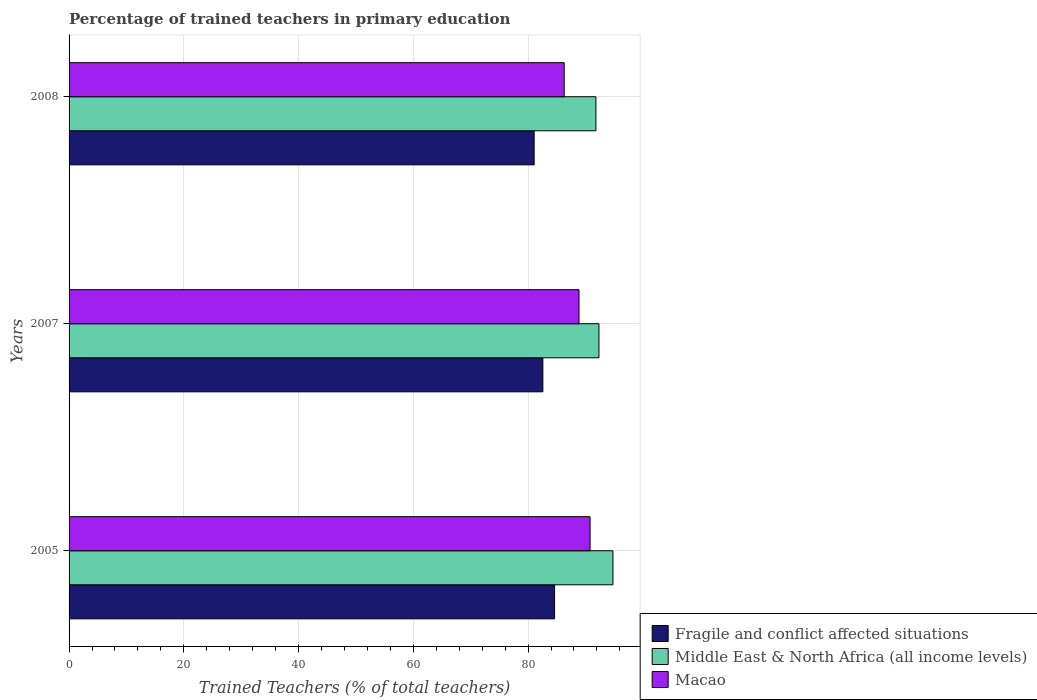How many groups of bars are there?
Your answer should be compact. 3. Are the number of bars on each tick of the Y-axis equal?
Ensure brevity in your answer.  Yes. What is the label of the 3rd group of bars from the top?
Provide a succinct answer. 2005. What is the percentage of trained teachers in Macao in 2008?
Provide a succinct answer. 86.3. Across all years, what is the maximum percentage of trained teachers in Middle East & North Africa (all income levels)?
Ensure brevity in your answer.  94.79. Across all years, what is the minimum percentage of trained teachers in Macao?
Provide a succinct answer. 86.3. In which year was the percentage of trained teachers in Middle East & North Africa (all income levels) minimum?
Keep it short and to the point. 2008. What is the total percentage of trained teachers in Macao in the graph?
Keep it short and to the point. 265.97. What is the difference between the percentage of trained teachers in Fragile and conflict affected situations in 2005 and that in 2008?
Your answer should be compact. 3.56. What is the difference between the percentage of trained teachers in Macao in 2005 and the percentage of trained teachers in Fragile and conflict affected situations in 2008?
Offer a terse response. 9.74. What is the average percentage of trained teachers in Middle East & North Africa (all income levels) per year?
Provide a succinct answer. 92.99. In the year 2005, what is the difference between the percentage of trained teachers in Middle East & North Africa (all income levels) and percentage of trained teachers in Macao?
Your answer should be compact. 3.99. What is the ratio of the percentage of trained teachers in Macao in 2005 to that in 2007?
Give a very brief answer. 1.02. Is the percentage of trained teachers in Macao in 2007 less than that in 2008?
Your answer should be very brief. No. Is the difference between the percentage of trained teachers in Middle East & North Africa (all income levels) in 2005 and 2008 greater than the difference between the percentage of trained teachers in Macao in 2005 and 2008?
Offer a terse response. No. What is the difference between the highest and the second highest percentage of trained teachers in Macao?
Your response must be concise. 1.93. What is the difference between the highest and the lowest percentage of trained teachers in Middle East & North Africa (all income levels)?
Offer a very short reply. 2.97. What does the 2nd bar from the top in 2005 represents?
Offer a terse response. Middle East & North Africa (all income levels). What does the 3rd bar from the bottom in 2005 represents?
Your answer should be compact. Macao. Is it the case that in every year, the sum of the percentage of trained teachers in Middle East & North Africa (all income levels) and percentage of trained teachers in Fragile and conflict affected situations is greater than the percentage of trained teachers in Macao?
Ensure brevity in your answer.  Yes. How many bars are there?
Offer a terse response. 9. Does the graph contain any zero values?
Your answer should be very brief. No. Does the graph contain grids?
Give a very brief answer. Yes. Where does the legend appear in the graph?
Ensure brevity in your answer.  Bottom right. How are the legend labels stacked?
Make the answer very short. Vertical. What is the title of the graph?
Offer a terse response. Percentage of trained teachers in primary education. Does "OECD members" appear as one of the legend labels in the graph?
Ensure brevity in your answer.  No. What is the label or title of the X-axis?
Your response must be concise. Trained Teachers (% of total teachers). What is the Trained Teachers (% of total teachers) in Fragile and conflict affected situations in 2005?
Give a very brief answer. 84.61. What is the Trained Teachers (% of total teachers) of Middle East & North Africa (all income levels) in 2005?
Offer a terse response. 94.79. What is the Trained Teachers (% of total teachers) of Macao in 2005?
Offer a terse response. 90.8. What is the Trained Teachers (% of total teachers) in Fragile and conflict affected situations in 2007?
Provide a short and direct response. 82.58. What is the Trained Teachers (% of total teachers) of Middle East & North Africa (all income levels) in 2007?
Offer a terse response. 92.35. What is the Trained Teachers (% of total teachers) in Macao in 2007?
Provide a succinct answer. 88.88. What is the Trained Teachers (% of total teachers) of Fragile and conflict affected situations in 2008?
Your response must be concise. 81.06. What is the Trained Teachers (% of total teachers) in Middle East & North Africa (all income levels) in 2008?
Make the answer very short. 91.82. What is the Trained Teachers (% of total teachers) of Macao in 2008?
Ensure brevity in your answer.  86.3. Across all years, what is the maximum Trained Teachers (% of total teachers) of Fragile and conflict affected situations?
Your response must be concise. 84.61. Across all years, what is the maximum Trained Teachers (% of total teachers) in Middle East & North Africa (all income levels)?
Make the answer very short. 94.79. Across all years, what is the maximum Trained Teachers (% of total teachers) in Macao?
Offer a terse response. 90.8. Across all years, what is the minimum Trained Teachers (% of total teachers) in Fragile and conflict affected situations?
Give a very brief answer. 81.06. Across all years, what is the minimum Trained Teachers (% of total teachers) of Middle East & North Africa (all income levels)?
Make the answer very short. 91.82. Across all years, what is the minimum Trained Teachers (% of total teachers) of Macao?
Ensure brevity in your answer.  86.3. What is the total Trained Teachers (% of total teachers) of Fragile and conflict affected situations in the graph?
Your answer should be compact. 248.25. What is the total Trained Teachers (% of total teachers) of Middle East & North Africa (all income levels) in the graph?
Provide a short and direct response. 278.97. What is the total Trained Teachers (% of total teachers) in Macao in the graph?
Make the answer very short. 265.97. What is the difference between the Trained Teachers (% of total teachers) in Fragile and conflict affected situations in 2005 and that in 2007?
Your answer should be compact. 2.04. What is the difference between the Trained Teachers (% of total teachers) of Middle East & North Africa (all income levels) in 2005 and that in 2007?
Ensure brevity in your answer.  2.44. What is the difference between the Trained Teachers (% of total teachers) in Macao in 2005 and that in 2007?
Offer a very short reply. 1.93. What is the difference between the Trained Teachers (% of total teachers) in Fragile and conflict affected situations in 2005 and that in 2008?
Offer a very short reply. 3.56. What is the difference between the Trained Teachers (% of total teachers) in Middle East & North Africa (all income levels) in 2005 and that in 2008?
Offer a very short reply. 2.97. What is the difference between the Trained Teachers (% of total teachers) in Macao in 2005 and that in 2008?
Your response must be concise. 4.51. What is the difference between the Trained Teachers (% of total teachers) in Fragile and conflict affected situations in 2007 and that in 2008?
Offer a terse response. 1.52. What is the difference between the Trained Teachers (% of total teachers) in Middle East & North Africa (all income levels) in 2007 and that in 2008?
Your response must be concise. 0.53. What is the difference between the Trained Teachers (% of total teachers) of Macao in 2007 and that in 2008?
Give a very brief answer. 2.58. What is the difference between the Trained Teachers (% of total teachers) in Fragile and conflict affected situations in 2005 and the Trained Teachers (% of total teachers) in Middle East & North Africa (all income levels) in 2007?
Offer a very short reply. -7.74. What is the difference between the Trained Teachers (% of total teachers) of Fragile and conflict affected situations in 2005 and the Trained Teachers (% of total teachers) of Macao in 2007?
Your answer should be compact. -4.26. What is the difference between the Trained Teachers (% of total teachers) of Middle East & North Africa (all income levels) in 2005 and the Trained Teachers (% of total teachers) of Macao in 2007?
Your answer should be very brief. 5.92. What is the difference between the Trained Teachers (% of total teachers) in Fragile and conflict affected situations in 2005 and the Trained Teachers (% of total teachers) in Middle East & North Africa (all income levels) in 2008?
Offer a very short reply. -7.21. What is the difference between the Trained Teachers (% of total teachers) in Fragile and conflict affected situations in 2005 and the Trained Teachers (% of total teachers) in Macao in 2008?
Offer a very short reply. -1.68. What is the difference between the Trained Teachers (% of total teachers) of Middle East & North Africa (all income levels) in 2005 and the Trained Teachers (% of total teachers) of Macao in 2008?
Provide a succinct answer. 8.5. What is the difference between the Trained Teachers (% of total teachers) in Fragile and conflict affected situations in 2007 and the Trained Teachers (% of total teachers) in Middle East & North Africa (all income levels) in 2008?
Offer a terse response. -9.25. What is the difference between the Trained Teachers (% of total teachers) in Fragile and conflict affected situations in 2007 and the Trained Teachers (% of total teachers) in Macao in 2008?
Make the answer very short. -3.72. What is the difference between the Trained Teachers (% of total teachers) of Middle East & North Africa (all income levels) in 2007 and the Trained Teachers (% of total teachers) of Macao in 2008?
Keep it short and to the point. 6.06. What is the average Trained Teachers (% of total teachers) in Fragile and conflict affected situations per year?
Provide a succinct answer. 82.75. What is the average Trained Teachers (% of total teachers) in Middle East & North Africa (all income levels) per year?
Offer a terse response. 92.99. What is the average Trained Teachers (% of total teachers) of Macao per year?
Your answer should be very brief. 88.66. In the year 2005, what is the difference between the Trained Teachers (% of total teachers) in Fragile and conflict affected situations and Trained Teachers (% of total teachers) in Middle East & North Africa (all income levels)?
Give a very brief answer. -10.18. In the year 2005, what is the difference between the Trained Teachers (% of total teachers) in Fragile and conflict affected situations and Trained Teachers (% of total teachers) in Macao?
Provide a short and direct response. -6.19. In the year 2005, what is the difference between the Trained Teachers (% of total teachers) in Middle East & North Africa (all income levels) and Trained Teachers (% of total teachers) in Macao?
Provide a short and direct response. 3.99. In the year 2007, what is the difference between the Trained Teachers (% of total teachers) in Fragile and conflict affected situations and Trained Teachers (% of total teachers) in Middle East & North Africa (all income levels)?
Offer a terse response. -9.78. In the year 2007, what is the difference between the Trained Teachers (% of total teachers) of Fragile and conflict affected situations and Trained Teachers (% of total teachers) of Macao?
Offer a terse response. -6.3. In the year 2007, what is the difference between the Trained Teachers (% of total teachers) of Middle East & North Africa (all income levels) and Trained Teachers (% of total teachers) of Macao?
Your answer should be very brief. 3.48. In the year 2008, what is the difference between the Trained Teachers (% of total teachers) in Fragile and conflict affected situations and Trained Teachers (% of total teachers) in Middle East & North Africa (all income levels)?
Your response must be concise. -10.77. In the year 2008, what is the difference between the Trained Teachers (% of total teachers) of Fragile and conflict affected situations and Trained Teachers (% of total teachers) of Macao?
Offer a very short reply. -5.24. In the year 2008, what is the difference between the Trained Teachers (% of total teachers) of Middle East & North Africa (all income levels) and Trained Teachers (% of total teachers) of Macao?
Your response must be concise. 5.53. What is the ratio of the Trained Teachers (% of total teachers) of Fragile and conflict affected situations in 2005 to that in 2007?
Make the answer very short. 1.02. What is the ratio of the Trained Teachers (% of total teachers) in Middle East & North Africa (all income levels) in 2005 to that in 2007?
Offer a very short reply. 1.03. What is the ratio of the Trained Teachers (% of total teachers) of Macao in 2005 to that in 2007?
Your answer should be very brief. 1.02. What is the ratio of the Trained Teachers (% of total teachers) of Fragile and conflict affected situations in 2005 to that in 2008?
Keep it short and to the point. 1.04. What is the ratio of the Trained Teachers (% of total teachers) in Middle East & North Africa (all income levels) in 2005 to that in 2008?
Make the answer very short. 1.03. What is the ratio of the Trained Teachers (% of total teachers) of Macao in 2005 to that in 2008?
Your answer should be compact. 1.05. What is the ratio of the Trained Teachers (% of total teachers) in Fragile and conflict affected situations in 2007 to that in 2008?
Offer a terse response. 1.02. What is the ratio of the Trained Teachers (% of total teachers) in Macao in 2007 to that in 2008?
Give a very brief answer. 1.03. What is the difference between the highest and the second highest Trained Teachers (% of total teachers) in Fragile and conflict affected situations?
Ensure brevity in your answer.  2.04. What is the difference between the highest and the second highest Trained Teachers (% of total teachers) of Middle East & North Africa (all income levels)?
Provide a succinct answer. 2.44. What is the difference between the highest and the second highest Trained Teachers (% of total teachers) in Macao?
Provide a short and direct response. 1.93. What is the difference between the highest and the lowest Trained Teachers (% of total teachers) in Fragile and conflict affected situations?
Ensure brevity in your answer.  3.56. What is the difference between the highest and the lowest Trained Teachers (% of total teachers) of Middle East & North Africa (all income levels)?
Offer a terse response. 2.97. What is the difference between the highest and the lowest Trained Teachers (% of total teachers) in Macao?
Offer a terse response. 4.51. 